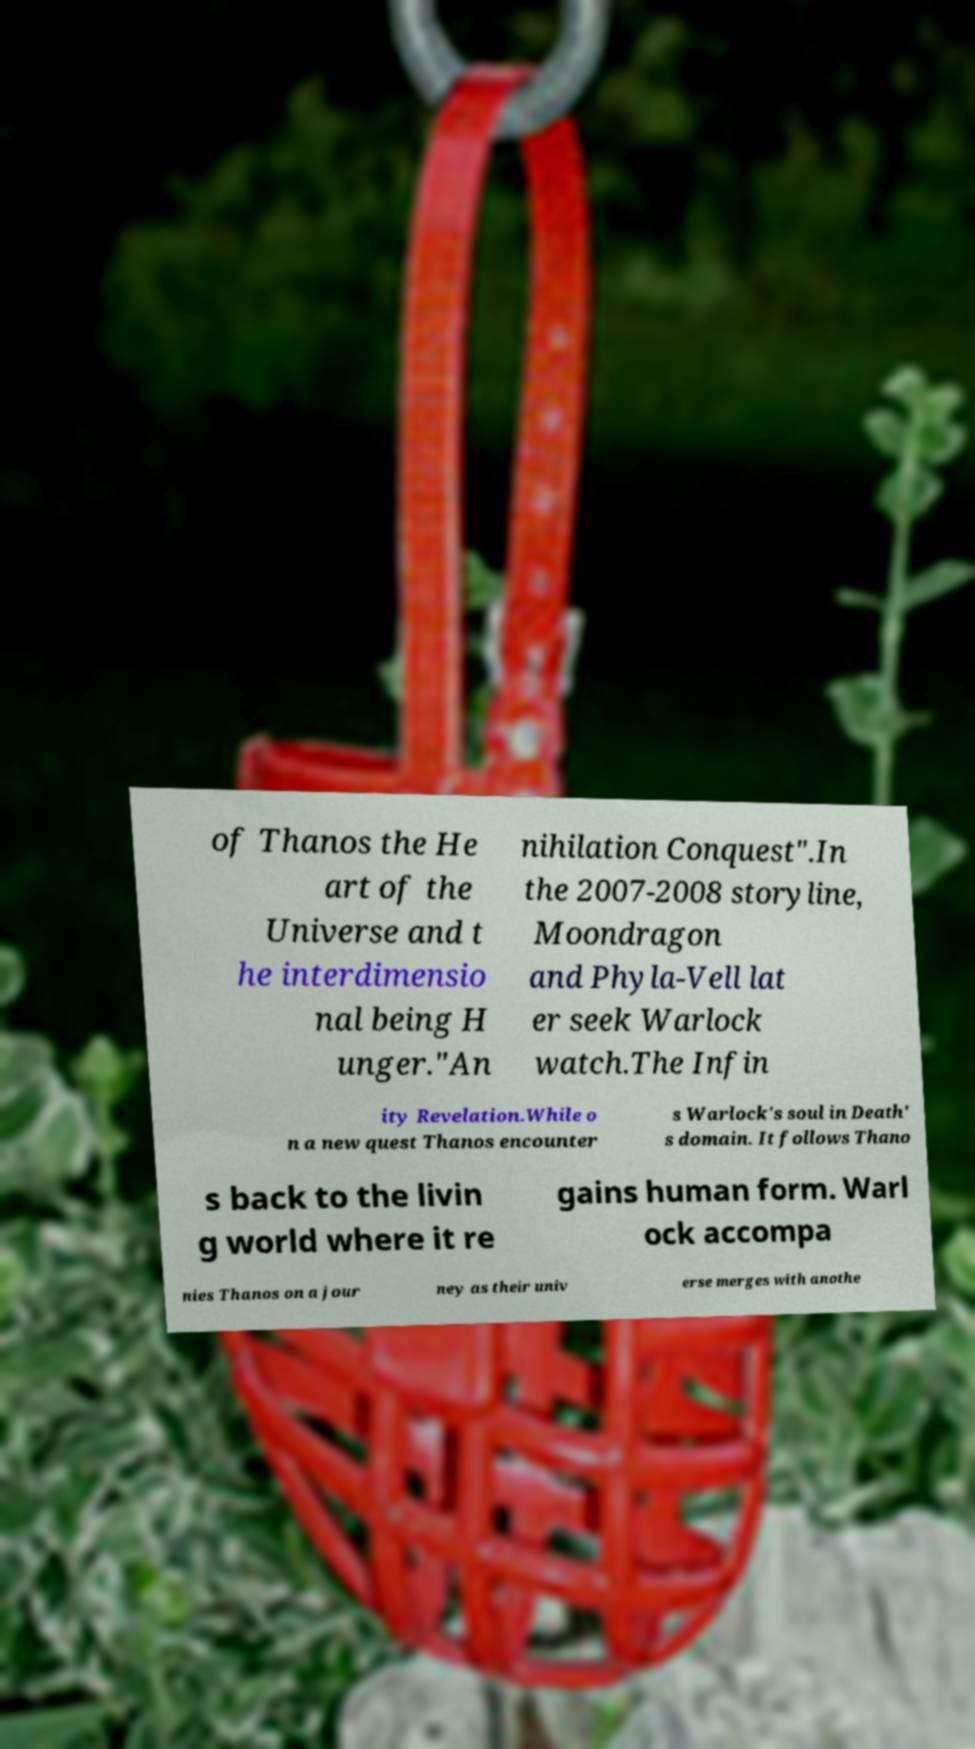There's text embedded in this image that I need extracted. Can you transcribe it verbatim? of Thanos the He art of the Universe and t he interdimensio nal being H unger."An nihilation Conquest".In the 2007-2008 storyline, Moondragon and Phyla-Vell lat er seek Warlock watch.The Infin ity Revelation.While o n a new quest Thanos encounter s Warlock's soul in Death' s domain. It follows Thano s back to the livin g world where it re gains human form. Warl ock accompa nies Thanos on a jour ney as their univ erse merges with anothe 